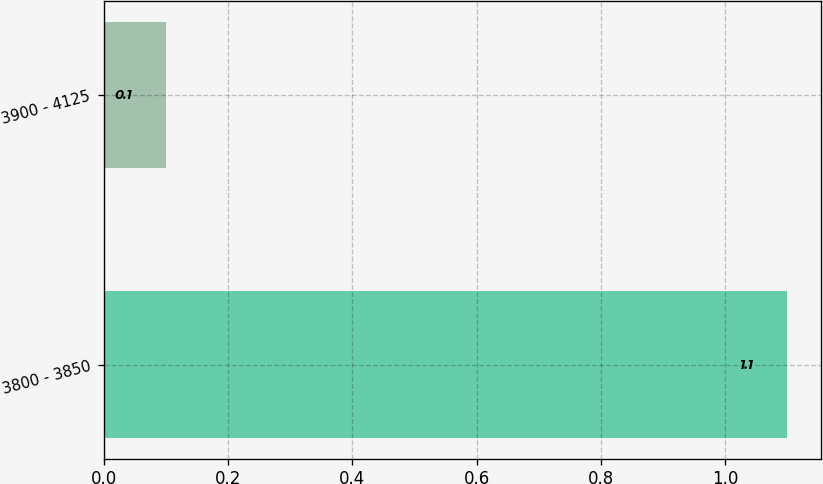Convert chart to OTSL. <chart><loc_0><loc_0><loc_500><loc_500><bar_chart><fcel>3800 - 3850<fcel>3900 - 4125<nl><fcel>1.1<fcel>0.1<nl></chart> 